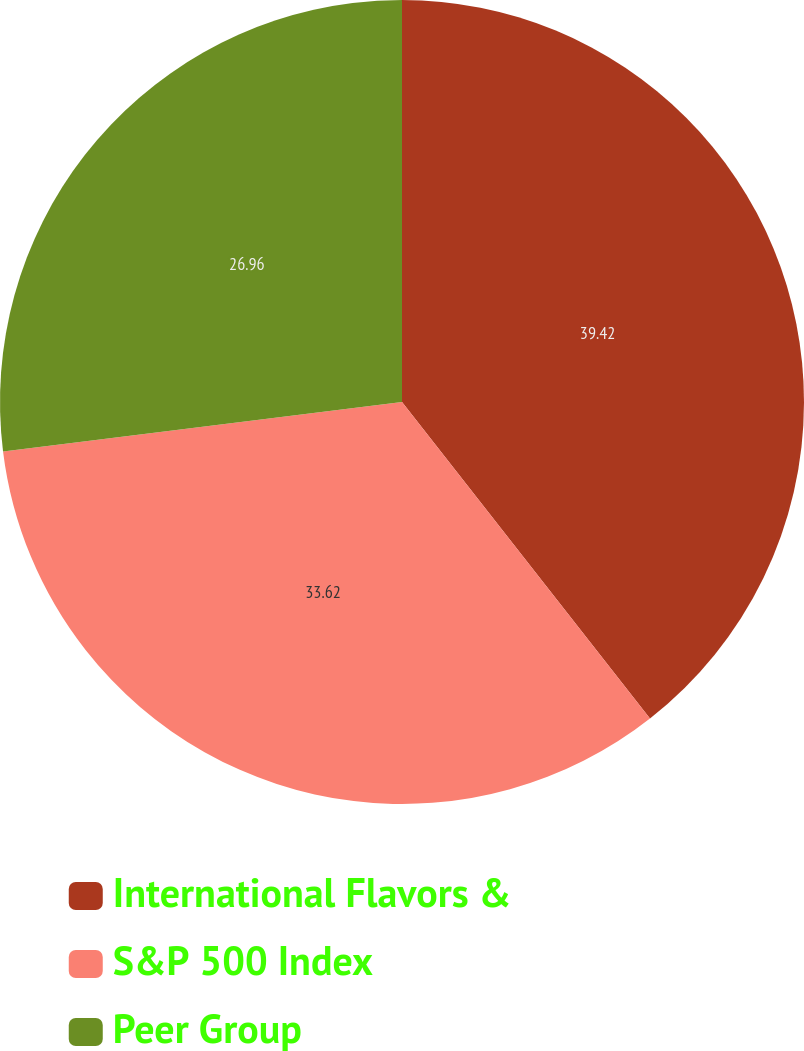Convert chart to OTSL. <chart><loc_0><loc_0><loc_500><loc_500><pie_chart><fcel>International Flavors &<fcel>S&P 500 Index<fcel>Peer Group<nl><fcel>39.42%<fcel>33.62%<fcel>26.96%<nl></chart> 